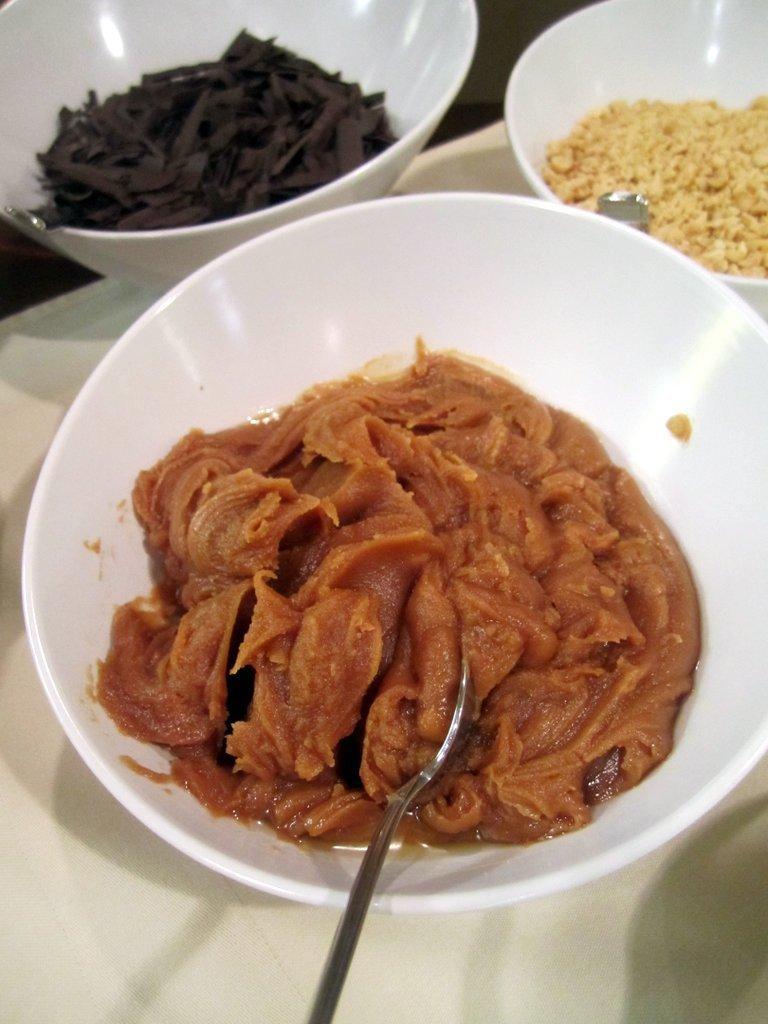Can you describe this image briefly? In this image I can see few food items in the white color bowls. I can see a spoon and they are on the white surface. 